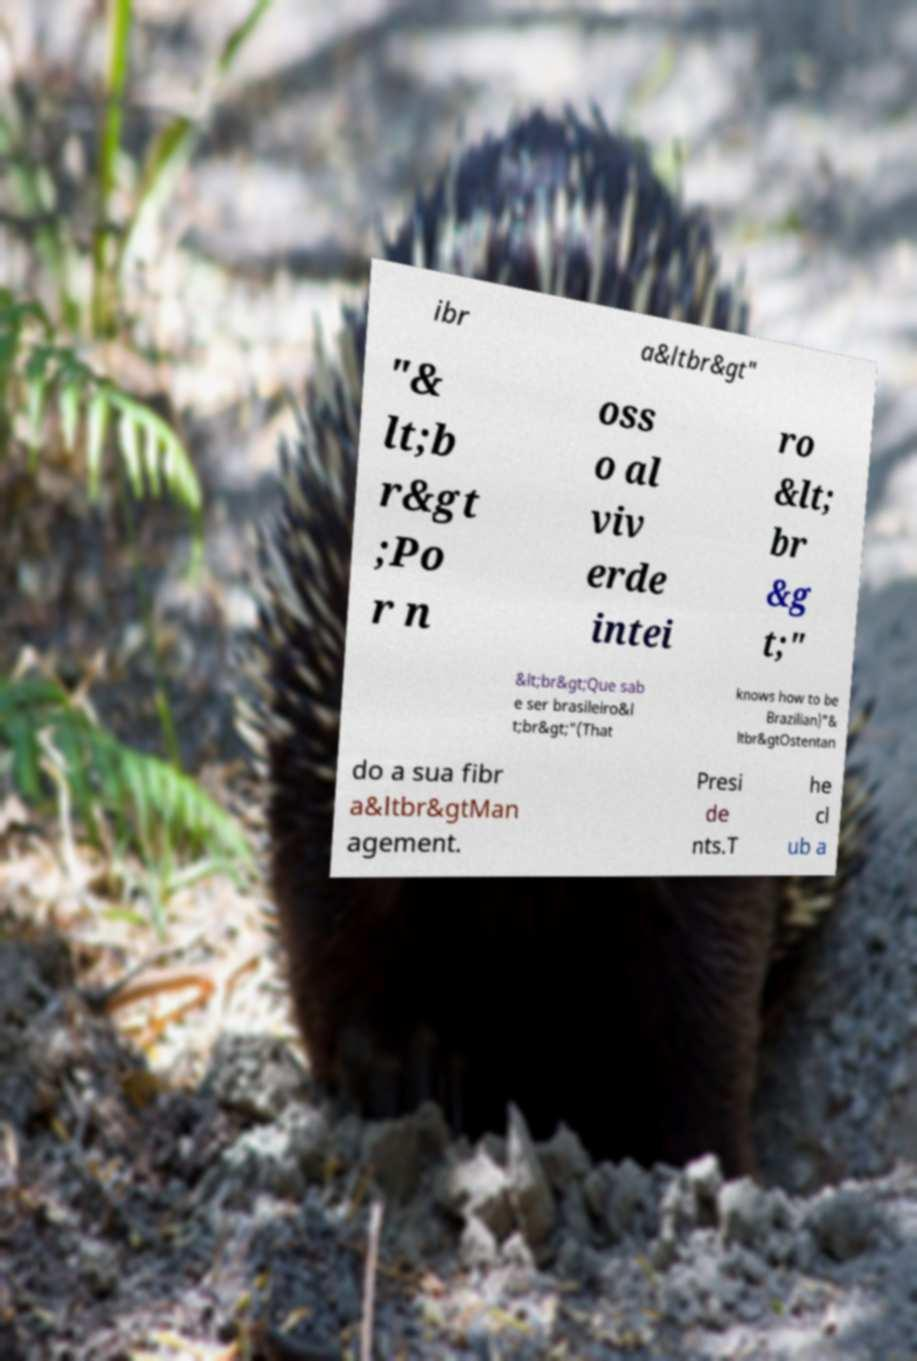Please identify and transcribe the text found in this image. ibr a&ltbr&gt" "& lt;b r&gt ;Po r n oss o al viv erde intei ro &lt; br &g t;" &lt;br&gt;Que sab e ser brasileiro&l t;br&gt;"(That knows how to be Brazilian)"& ltbr&gtOstentan do a sua fibr a&ltbr&gtMan agement. Presi de nts.T he cl ub a 